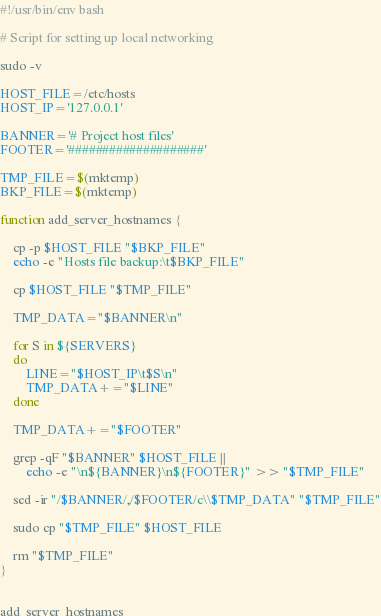<code> <loc_0><loc_0><loc_500><loc_500><_Bash_>#!/usr/bin/env bash

# Script for setting up local networking

sudo -v

HOST_FILE=/etc/hosts
HOST_IP='127.0.0.1'

BANNER='# Project host files'
FOOTER='####################'

TMP_FILE=$(mktemp)
BKP_FILE=$(mktemp)

function add_server_hostnames {

    cp -p $HOST_FILE "$BKP_FILE"
    echo -e "Hosts file backup:\t$BKP_FILE"

    cp $HOST_FILE "$TMP_FILE"

    TMP_DATA="$BANNER\n"

    for S in ${SERVERS}
    do
        LINE="$HOST_IP\t$S\n"
        TMP_DATA+="$LINE"
    done

    TMP_DATA+="$FOOTER"

    grep -qF "$BANNER" $HOST_FILE ||
        echo -e "\n${BANNER}\n${FOOTER}" >> "$TMP_FILE"

    sed -ir "/$BANNER/,/$FOOTER/c\\$TMP_DATA" "$TMP_FILE"

    sudo cp "$TMP_FILE" $HOST_FILE

    rm "$TMP_FILE"
}


add_server_hostnames
</code> 